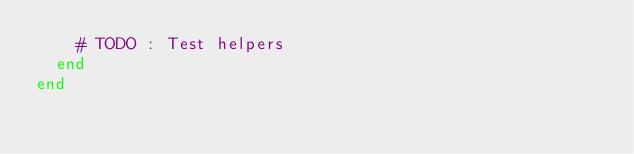<code> <loc_0><loc_0><loc_500><loc_500><_Crystal_>    # TODO : Test helpers
  end
end
</code> 